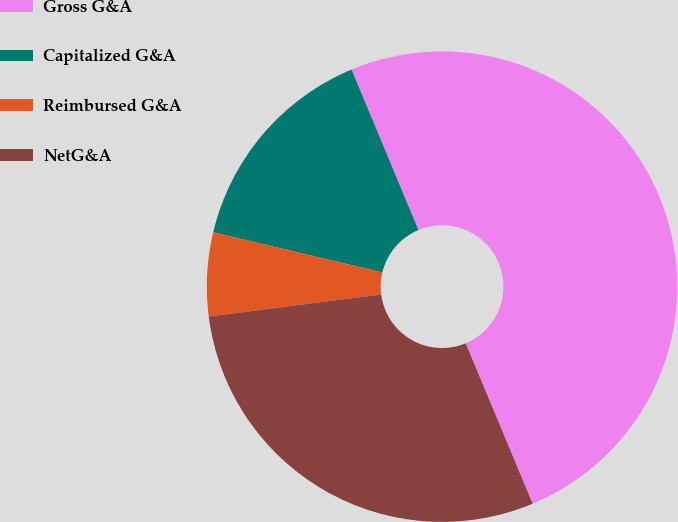<chart> <loc_0><loc_0><loc_500><loc_500><pie_chart><fcel>Gross G&A<fcel>Capitalized G&A<fcel>Reimbursed G&A<fcel>NetG&A<nl><fcel>50.0%<fcel>15.0%<fcel>5.74%<fcel>29.27%<nl></chart> 